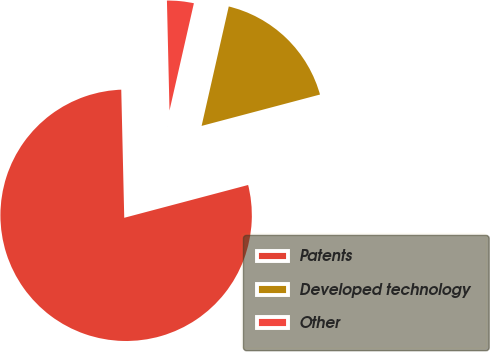<chart> <loc_0><loc_0><loc_500><loc_500><pie_chart><fcel>Patents<fcel>Developed technology<fcel>Other<nl><fcel>78.75%<fcel>17.32%<fcel>3.93%<nl></chart> 